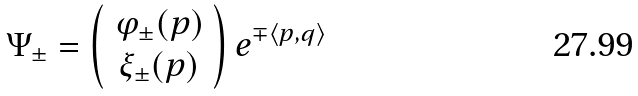Convert formula to latex. <formula><loc_0><loc_0><loc_500><loc_500>\Psi _ { \pm } = \left ( \begin{array} { c } \varphi _ { \pm } ( p ) \\ \xi _ { \pm } ( p ) \end{array} \right ) e ^ { \mp \langle p , q \rangle }</formula> 